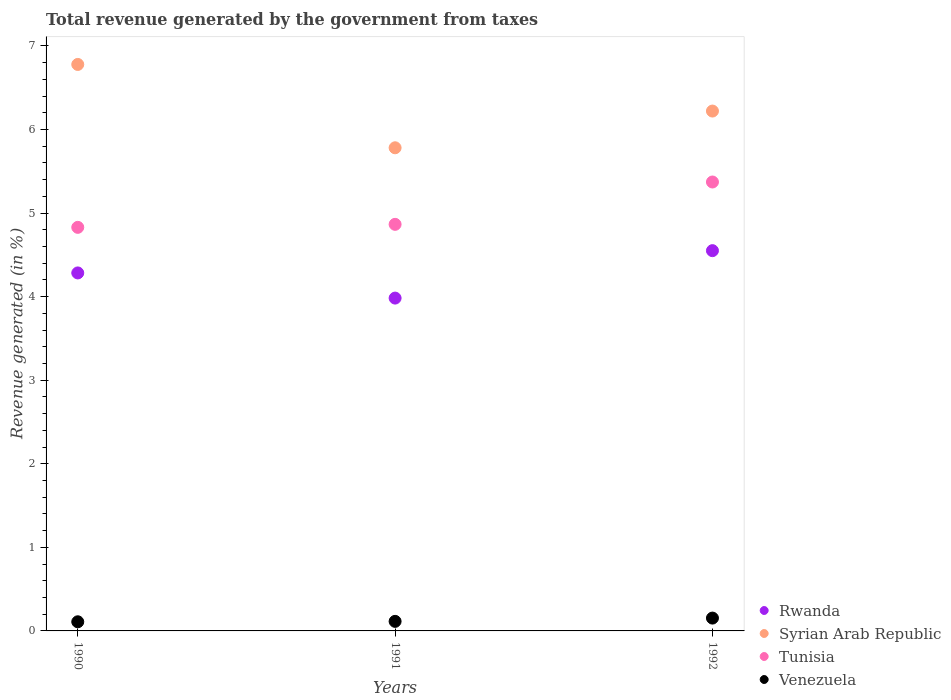How many different coloured dotlines are there?
Your answer should be compact. 4. Is the number of dotlines equal to the number of legend labels?
Give a very brief answer. Yes. What is the total revenue generated in Venezuela in 1992?
Offer a very short reply. 0.15. Across all years, what is the maximum total revenue generated in Venezuela?
Your answer should be compact. 0.15. Across all years, what is the minimum total revenue generated in Syrian Arab Republic?
Your answer should be compact. 5.78. In which year was the total revenue generated in Venezuela maximum?
Make the answer very short. 1992. What is the total total revenue generated in Rwanda in the graph?
Provide a succinct answer. 12.82. What is the difference between the total revenue generated in Rwanda in 1990 and that in 1992?
Ensure brevity in your answer.  -0.27. What is the difference between the total revenue generated in Venezuela in 1991 and the total revenue generated in Rwanda in 1990?
Give a very brief answer. -4.17. What is the average total revenue generated in Tunisia per year?
Your answer should be very brief. 5.02. In the year 1992, what is the difference between the total revenue generated in Venezuela and total revenue generated in Rwanda?
Give a very brief answer. -4.4. What is the ratio of the total revenue generated in Rwanda in 1990 to that in 1992?
Your answer should be very brief. 0.94. Is the total revenue generated in Venezuela in 1990 less than that in 1992?
Your answer should be compact. Yes. Is the difference between the total revenue generated in Venezuela in 1990 and 1992 greater than the difference between the total revenue generated in Rwanda in 1990 and 1992?
Ensure brevity in your answer.  Yes. What is the difference between the highest and the second highest total revenue generated in Tunisia?
Make the answer very short. 0.51. What is the difference between the highest and the lowest total revenue generated in Syrian Arab Republic?
Keep it short and to the point. 1. In how many years, is the total revenue generated in Rwanda greater than the average total revenue generated in Rwanda taken over all years?
Make the answer very short. 2. Is it the case that in every year, the sum of the total revenue generated in Syrian Arab Republic and total revenue generated in Rwanda  is greater than the sum of total revenue generated in Tunisia and total revenue generated in Venezuela?
Offer a very short reply. Yes. Does the total revenue generated in Rwanda monotonically increase over the years?
Ensure brevity in your answer.  No. Are the values on the major ticks of Y-axis written in scientific E-notation?
Ensure brevity in your answer.  No. Does the graph contain grids?
Provide a succinct answer. No. Where does the legend appear in the graph?
Your answer should be very brief. Bottom right. How many legend labels are there?
Make the answer very short. 4. How are the legend labels stacked?
Give a very brief answer. Vertical. What is the title of the graph?
Offer a very short reply. Total revenue generated by the government from taxes. What is the label or title of the X-axis?
Provide a succinct answer. Years. What is the label or title of the Y-axis?
Ensure brevity in your answer.  Revenue generated (in %). What is the Revenue generated (in %) of Rwanda in 1990?
Your answer should be compact. 4.28. What is the Revenue generated (in %) of Syrian Arab Republic in 1990?
Provide a succinct answer. 6.78. What is the Revenue generated (in %) of Tunisia in 1990?
Your answer should be compact. 4.83. What is the Revenue generated (in %) of Venezuela in 1990?
Make the answer very short. 0.11. What is the Revenue generated (in %) of Rwanda in 1991?
Provide a succinct answer. 3.98. What is the Revenue generated (in %) of Syrian Arab Republic in 1991?
Provide a succinct answer. 5.78. What is the Revenue generated (in %) of Tunisia in 1991?
Your response must be concise. 4.87. What is the Revenue generated (in %) of Venezuela in 1991?
Provide a succinct answer. 0.11. What is the Revenue generated (in %) in Rwanda in 1992?
Keep it short and to the point. 4.55. What is the Revenue generated (in %) in Syrian Arab Republic in 1992?
Give a very brief answer. 6.22. What is the Revenue generated (in %) of Tunisia in 1992?
Give a very brief answer. 5.37. What is the Revenue generated (in %) in Venezuela in 1992?
Keep it short and to the point. 0.15. Across all years, what is the maximum Revenue generated (in %) in Rwanda?
Offer a very short reply. 4.55. Across all years, what is the maximum Revenue generated (in %) in Syrian Arab Republic?
Your answer should be very brief. 6.78. Across all years, what is the maximum Revenue generated (in %) of Tunisia?
Keep it short and to the point. 5.37. Across all years, what is the maximum Revenue generated (in %) in Venezuela?
Provide a succinct answer. 0.15. Across all years, what is the minimum Revenue generated (in %) of Rwanda?
Provide a short and direct response. 3.98. Across all years, what is the minimum Revenue generated (in %) in Syrian Arab Republic?
Give a very brief answer. 5.78. Across all years, what is the minimum Revenue generated (in %) in Tunisia?
Provide a short and direct response. 4.83. Across all years, what is the minimum Revenue generated (in %) of Venezuela?
Your response must be concise. 0.11. What is the total Revenue generated (in %) of Rwanda in the graph?
Your response must be concise. 12.82. What is the total Revenue generated (in %) in Syrian Arab Republic in the graph?
Provide a succinct answer. 18.78. What is the total Revenue generated (in %) of Tunisia in the graph?
Your answer should be compact. 15.07. What is the total Revenue generated (in %) of Venezuela in the graph?
Make the answer very short. 0.38. What is the difference between the Revenue generated (in %) of Rwanda in 1990 and that in 1991?
Offer a very short reply. 0.3. What is the difference between the Revenue generated (in %) in Syrian Arab Republic in 1990 and that in 1991?
Give a very brief answer. 1. What is the difference between the Revenue generated (in %) of Tunisia in 1990 and that in 1991?
Offer a very short reply. -0.04. What is the difference between the Revenue generated (in %) of Venezuela in 1990 and that in 1991?
Provide a succinct answer. -0.01. What is the difference between the Revenue generated (in %) of Rwanda in 1990 and that in 1992?
Offer a very short reply. -0.27. What is the difference between the Revenue generated (in %) of Syrian Arab Republic in 1990 and that in 1992?
Offer a terse response. 0.56. What is the difference between the Revenue generated (in %) in Tunisia in 1990 and that in 1992?
Ensure brevity in your answer.  -0.54. What is the difference between the Revenue generated (in %) of Venezuela in 1990 and that in 1992?
Offer a terse response. -0.04. What is the difference between the Revenue generated (in %) of Rwanda in 1991 and that in 1992?
Make the answer very short. -0.57. What is the difference between the Revenue generated (in %) of Syrian Arab Republic in 1991 and that in 1992?
Your answer should be very brief. -0.44. What is the difference between the Revenue generated (in %) of Tunisia in 1991 and that in 1992?
Offer a terse response. -0.51. What is the difference between the Revenue generated (in %) in Venezuela in 1991 and that in 1992?
Your response must be concise. -0.04. What is the difference between the Revenue generated (in %) of Rwanda in 1990 and the Revenue generated (in %) of Syrian Arab Republic in 1991?
Make the answer very short. -1.5. What is the difference between the Revenue generated (in %) in Rwanda in 1990 and the Revenue generated (in %) in Tunisia in 1991?
Provide a succinct answer. -0.58. What is the difference between the Revenue generated (in %) of Rwanda in 1990 and the Revenue generated (in %) of Venezuela in 1991?
Provide a short and direct response. 4.17. What is the difference between the Revenue generated (in %) in Syrian Arab Republic in 1990 and the Revenue generated (in %) in Tunisia in 1991?
Your answer should be compact. 1.91. What is the difference between the Revenue generated (in %) of Syrian Arab Republic in 1990 and the Revenue generated (in %) of Venezuela in 1991?
Give a very brief answer. 6.66. What is the difference between the Revenue generated (in %) of Tunisia in 1990 and the Revenue generated (in %) of Venezuela in 1991?
Offer a terse response. 4.72. What is the difference between the Revenue generated (in %) of Rwanda in 1990 and the Revenue generated (in %) of Syrian Arab Republic in 1992?
Offer a very short reply. -1.94. What is the difference between the Revenue generated (in %) in Rwanda in 1990 and the Revenue generated (in %) in Tunisia in 1992?
Offer a terse response. -1.09. What is the difference between the Revenue generated (in %) in Rwanda in 1990 and the Revenue generated (in %) in Venezuela in 1992?
Keep it short and to the point. 4.13. What is the difference between the Revenue generated (in %) in Syrian Arab Republic in 1990 and the Revenue generated (in %) in Tunisia in 1992?
Provide a short and direct response. 1.41. What is the difference between the Revenue generated (in %) in Syrian Arab Republic in 1990 and the Revenue generated (in %) in Venezuela in 1992?
Provide a succinct answer. 6.63. What is the difference between the Revenue generated (in %) of Tunisia in 1990 and the Revenue generated (in %) of Venezuela in 1992?
Provide a short and direct response. 4.68. What is the difference between the Revenue generated (in %) in Rwanda in 1991 and the Revenue generated (in %) in Syrian Arab Republic in 1992?
Offer a terse response. -2.24. What is the difference between the Revenue generated (in %) in Rwanda in 1991 and the Revenue generated (in %) in Tunisia in 1992?
Give a very brief answer. -1.39. What is the difference between the Revenue generated (in %) of Rwanda in 1991 and the Revenue generated (in %) of Venezuela in 1992?
Offer a very short reply. 3.83. What is the difference between the Revenue generated (in %) in Syrian Arab Republic in 1991 and the Revenue generated (in %) in Tunisia in 1992?
Provide a succinct answer. 0.41. What is the difference between the Revenue generated (in %) in Syrian Arab Republic in 1991 and the Revenue generated (in %) in Venezuela in 1992?
Provide a short and direct response. 5.63. What is the difference between the Revenue generated (in %) of Tunisia in 1991 and the Revenue generated (in %) of Venezuela in 1992?
Keep it short and to the point. 4.71. What is the average Revenue generated (in %) in Rwanda per year?
Provide a short and direct response. 4.27. What is the average Revenue generated (in %) of Syrian Arab Republic per year?
Offer a very short reply. 6.26. What is the average Revenue generated (in %) of Tunisia per year?
Provide a succinct answer. 5.02. What is the average Revenue generated (in %) of Venezuela per year?
Your response must be concise. 0.13. In the year 1990, what is the difference between the Revenue generated (in %) in Rwanda and Revenue generated (in %) in Syrian Arab Republic?
Keep it short and to the point. -2.5. In the year 1990, what is the difference between the Revenue generated (in %) of Rwanda and Revenue generated (in %) of Tunisia?
Offer a very short reply. -0.55. In the year 1990, what is the difference between the Revenue generated (in %) in Rwanda and Revenue generated (in %) in Venezuela?
Provide a succinct answer. 4.17. In the year 1990, what is the difference between the Revenue generated (in %) of Syrian Arab Republic and Revenue generated (in %) of Tunisia?
Provide a short and direct response. 1.95. In the year 1990, what is the difference between the Revenue generated (in %) of Syrian Arab Republic and Revenue generated (in %) of Venezuela?
Your answer should be compact. 6.67. In the year 1990, what is the difference between the Revenue generated (in %) of Tunisia and Revenue generated (in %) of Venezuela?
Make the answer very short. 4.72. In the year 1991, what is the difference between the Revenue generated (in %) of Rwanda and Revenue generated (in %) of Syrian Arab Republic?
Your response must be concise. -1.8. In the year 1991, what is the difference between the Revenue generated (in %) of Rwanda and Revenue generated (in %) of Tunisia?
Your response must be concise. -0.88. In the year 1991, what is the difference between the Revenue generated (in %) in Rwanda and Revenue generated (in %) in Venezuela?
Provide a succinct answer. 3.87. In the year 1991, what is the difference between the Revenue generated (in %) of Syrian Arab Republic and Revenue generated (in %) of Tunisia?
Your answer should be very brief. 0.92. In the year 1991, what is the difference between the Revenue generated (in %) in Syrian Arab Republic and Revenue generated (in %) in Venezuela?
Provide a short and direct response. 5.67. In the year 1991, what is the difference between the Revenue generated (in %) in Tunisia and Revenue generated (in %) in Venezuela?
Ensure brevity in your answer.  4.75. In the year 1992, what is the difference between the Revenue generated (in %) of Rwanda and Revenue generated (in %) of Syrian Arab Republic?
Keep it short and to the point. -1.67. In the year 1992, what is the difference between the Revenue generated (in %) in Rwanda and Revenue generated (in %) in Tunisia?
Offer a very short reply. -0.82. In the year 1992, what is the difference between the Revenue generated (in %) in Rwanda and Revenue generated (in %) in Venezuela?
Provide a short and direct response. 4.4. In the year 1992, what is the difference between the Revenue generated (in %) in Syrian Arab Republic and Revenue generated (in %) in Tunisia?
Your response must be concise. 0.85. In the year 1992, what is the difference between the Revenue generated (in %) of Syrian Arab Republic and Revenue generated (in %) of Venezuela?
Provide a succinct answer. 6.07. In the year 1992, what is the difference between the Revenue generated (in %) of Tunisia and Revenue generated (in %) of Venezuela?
Keep it short and to the point. 5.22. What is the ratio of the Revenue generated (in %) in Rwanda in 1990 to that in 1991?
Make the answer very short. 1.08. What is the ratio of the Revenue generated (in %) in Syrian Arab Republic in 1990 to that in 1991?
Your response must be concise. 1.17. What is the ratio of the Revenue generated (in %) in Tunisia in 1990 to that in 1991?
Offer a very short reply. 0.99. What is the ratio of the Revenue generated (in %) of Venezuela in 1990 to that in 1991?
Make the answer very short. 0.96. What is the ratio of the Revenue generated (in %) in Rwanda in 1990 to that in 1992?
Offer a very short reply. 0.94. What is the ratio of the Revenue generated (in %) in Syrian Arab Republic in 1990 to that in 1992?
Keep it short and to the point. 1.09. What is the ratio of the Revenue generated (in %) in Tunisia in 1990 to that in 1992?
Keep it short and to the point. 0.9. What is the ratio of the Revenue generated (in %) in Venezuela in 1990 to that in 1992?
Ensure brevity in your answer.  0.71. What is the ratio of the Revenue generated (in %) of Rwanda in 1991 to that in 1992?
Offer a terse response. 0.88. What is the ratio of the Revenue generated (in %) in Syrian Arab Republic in 1991 to that in 1992?
Provide a succinct answer. 0.93. What is the ratio of the Revenue generated (in %) in Tunisia in 1991 to that in 1992?
Keep it short and to the point. 0.91. What is the ratio of the Revenue generated (in %) in Venezuela in 1991 to that in 1992?
Offer a very short reply. 0.74. What is the difference between the highest and the second highest Revenue generated (in %) in Rwanda?
Your answer should be very brief. 0.27. What is the difference between the highest and the second highest Revenue generated (in %) in Syrian Arab Republic?
Give a very brief answer. 0.56. What is the difference between the highest and the second highest Revenue generated (in %) of Tunisia?
Offer a terse response. 0.51. What is the difference between the highest and the second highest Revenue generated (in %) of Venezuela?
Your response must be concise. 0.04. What is the difference between the highest and the lowest Revenue generated (in %) of Rwanda?
Provide a short and direct response. 0.57. What is the difference between the highest and the lowest Revenue generated (in %) in Syrian Arab Republic?
Offer a terse response. 1. What is the difference between the highest and the lowest Revenue generated (in %) in Tunisia?
Provide a succinct answer. 0.54. What is the difference between the highest and the lowest Revenue generated (in %) in Venezuela?
Offer a very short reply. 0.04. 